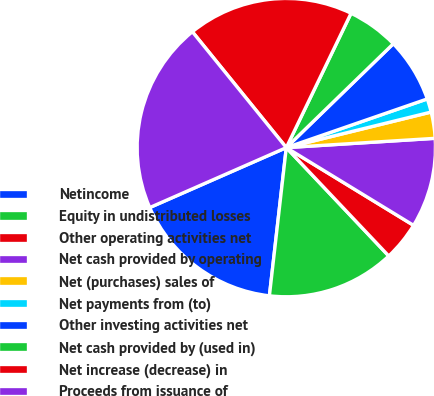<chart> <loc_0><loc_0><loc_500><loc_500><pie_chart><fcel>Netincome<fcel>Equity in undistributed losses<fcel>Other operating activities net<fcel>Net cash provided by operating<fcel>Net (purchases) sales of<fcel>Net payments from (to)<fcel>Other investing activities net<fcel>Net cash provided by (used in)<fcel>Net increase (decrease) in<fcel>Proceeds from issuance of<nl><fcel>16.61%<fcel>13.86%<fcel>4.22%<fcel>9.72%<fcel>2.84%<fcel>1.46%<fcel>6.97%<fcel>5.59%<fcel>17.99%<fcel>20.74%<nl></chart> 